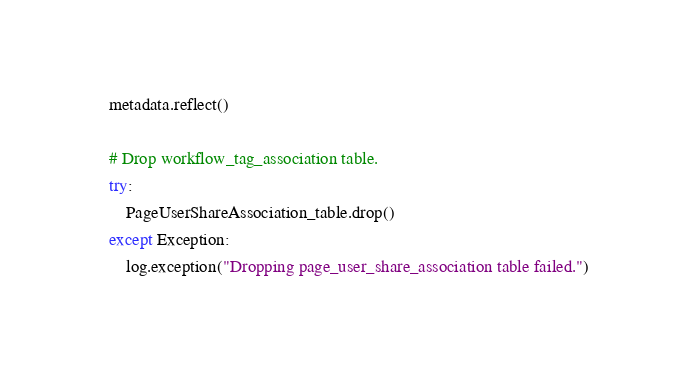Convert code to text. <code><loc_0><loc_0><loc_500><loc_500><_Python_>    metadata.reflect()

    # Drop workflow_tag_association table.
    try:
        PageUserShareAssociation_table.drop()
    except Exception:
        log.exception("Dropping page_user_share_association table failed.")
</code> 